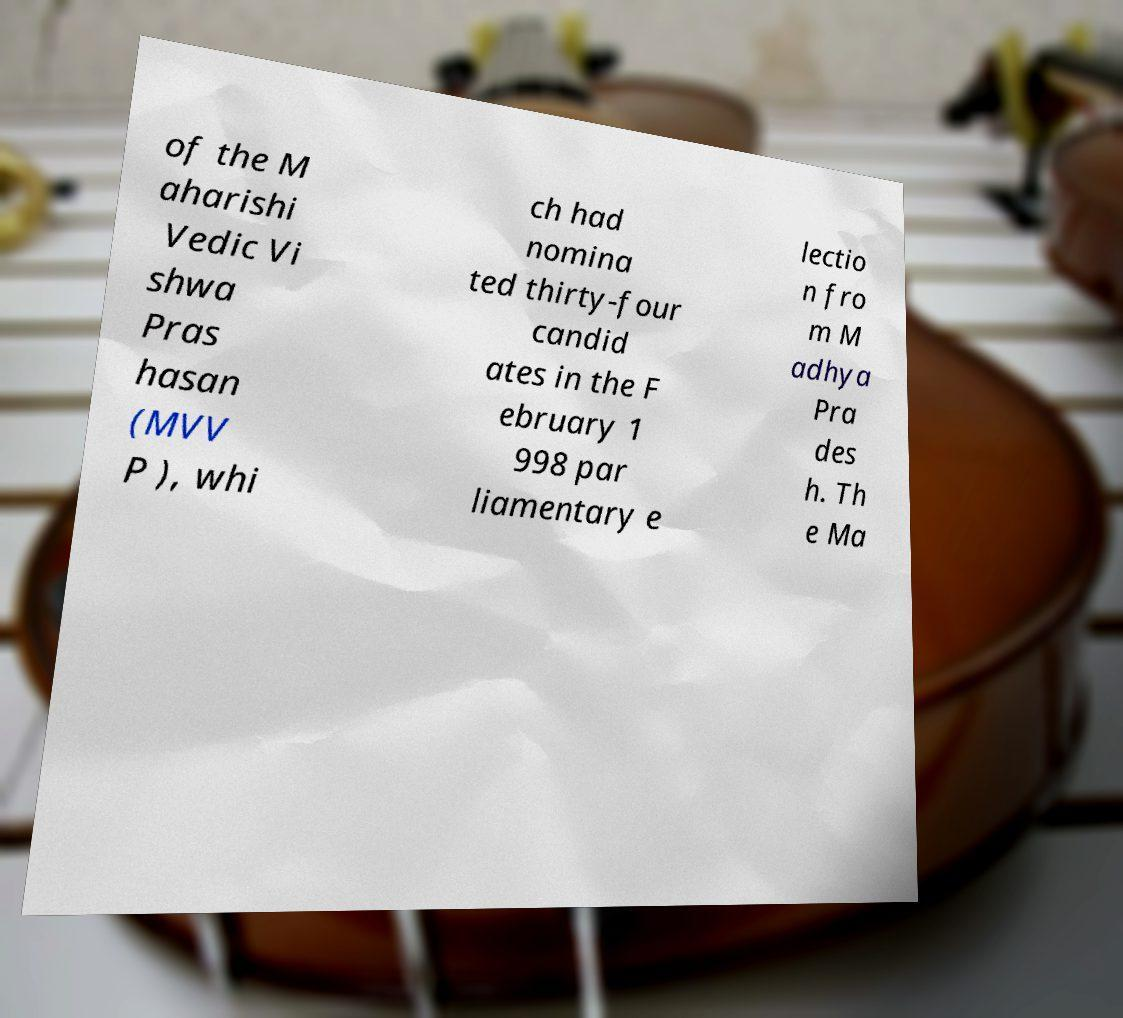What messages or text are displayed in this image? I need them in a readable, typed format. of the M aharishi Vedic Vi shwa Pras hasan (MVV P ), whi ch had nomina ted thirty-four candid ates in the F ebruary 1 998 par liamentary e lectio n fro m M adhya Pra des h. Th e Ma 